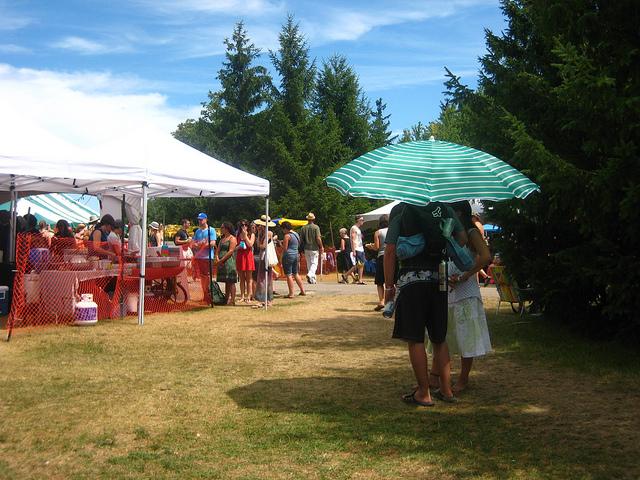What color is the woman's skirt?
Concise answer only. White. What color hat is the lady on the left wearing?
Short answer required. Black. Is she wearing shoes?
Answer briefly. Yes. Is the grass green?
Short answer required. Yes. How is the weather?
Write a very short answer. Sunny. Is dark outside?
Give a very brief answer. No. What color is the umbrella?
Concise answer only. Green and white. Are the umbrellas upside down?
Write a very short answer. No. What color is the tent?
Answer briefly. White. 